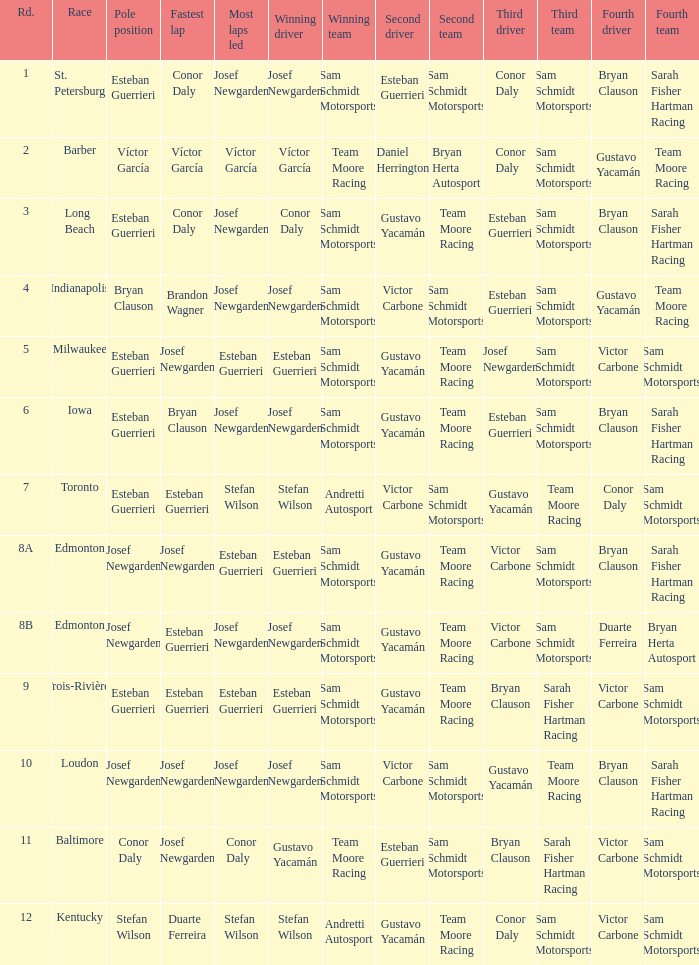Who had the pole(s) when esteban guerrieri led the most laps round 8a and josef newgarden had the fastest lap? Josef Newgarden. 